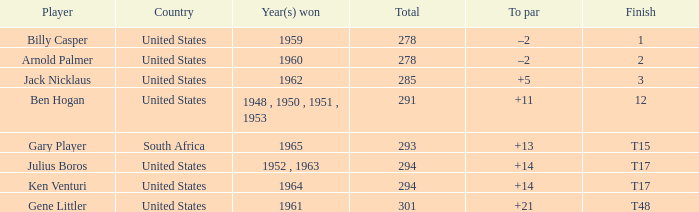What is Country, when Year(s) Won is "1962"? United States. 